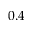Convert formula to latex. <formula><loc_0><loc_0><loc_500><loc_500>0 . 4</formula> 